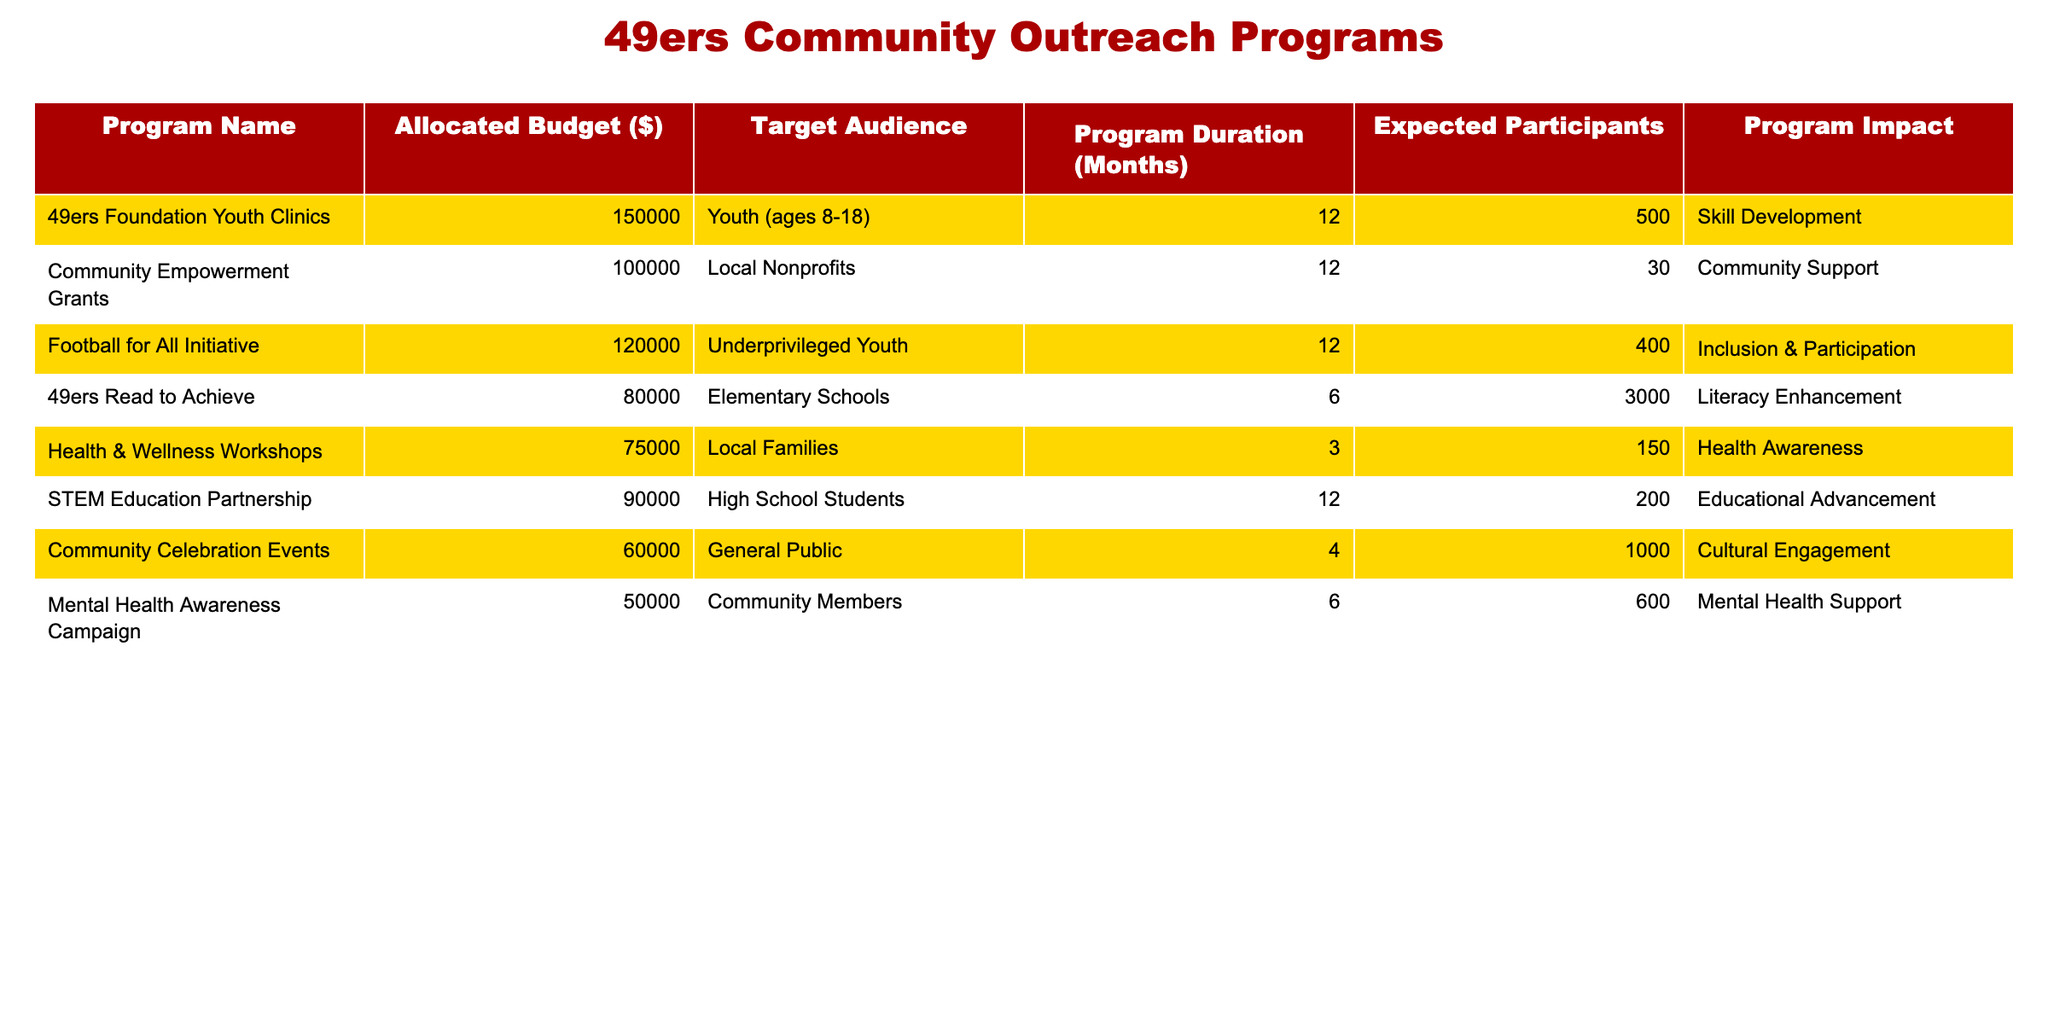What is the allocated budget for the 49ers Foundation Youth Clinics? The table indicates that the allocated budget for the 49ers Foundation Youth Clinics is 150,000 dollars.
Answer: 150,000 How many expected participants are there for the Community Celebration Events? According to the table, the Community Celebration Events are expected to have 1000 participants.
Answer: 1000 What is the total budget allocated for all programs targeting youth (ages 8-18)? The table shows two programs targeting youth: the 49ers Foundation Youth Clinics with an allocated budget of 150,000 dollars and the Football for All Initiative with 120,000 dollars. Adding these amounts gives 150,000 + 120,000 = 270,000 dollars.
Answer: 270,000 Is the allocated budget for the Mental Health Awareness Campaign more than that for the Health & Wellness Workshops? The Mental Health Awareness Campaign has an allocated budget of 50,000 dollars, while the Health & Wellness Workshops have 75,000 dollars. Since 50,000 is less than 75,000, the statement is false.
Answer: No What is the expected number of participants for the football-related initiatives combined? The football-related initiatives are the 49ers Foundation Youth Clinics (500 participants) and the Football for All Initiative (400 participants). The total expected participants from these programs is 500 + 400 = 900 participants.
Answer: 900 Which program has the shortest duration, and what is that duration? The Health & Wellness Workshops have a program duration of 3 months, which is less than any other program listed in the table.
Answer: 3 months What is the average budget allocation for all programs listed in the table? The total budget for all programs is 150,000 + 100,000 + 120,000 + 80,000 + 75,000 + 90,000 + 60,000 + 50,000 = 725,000 dollars. There are 8 programs, so the average budget allocation is 725,000 / 8 = 90,625 dollars.
Answer: 90,625 Are more expected participants associated with the 49ers Read to Achieve program compared to the Health & Wellness Workshops? The expected participants for the 49ers Read to Achieve program is 3,000, while for the Health & Wellness Workshops it is 150. Since 3,000 is greater than 150, the statement is true.
Answer: Yes 